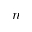<formula> <loc_0><loc_0><loc_500><loc_500>n</formula> 